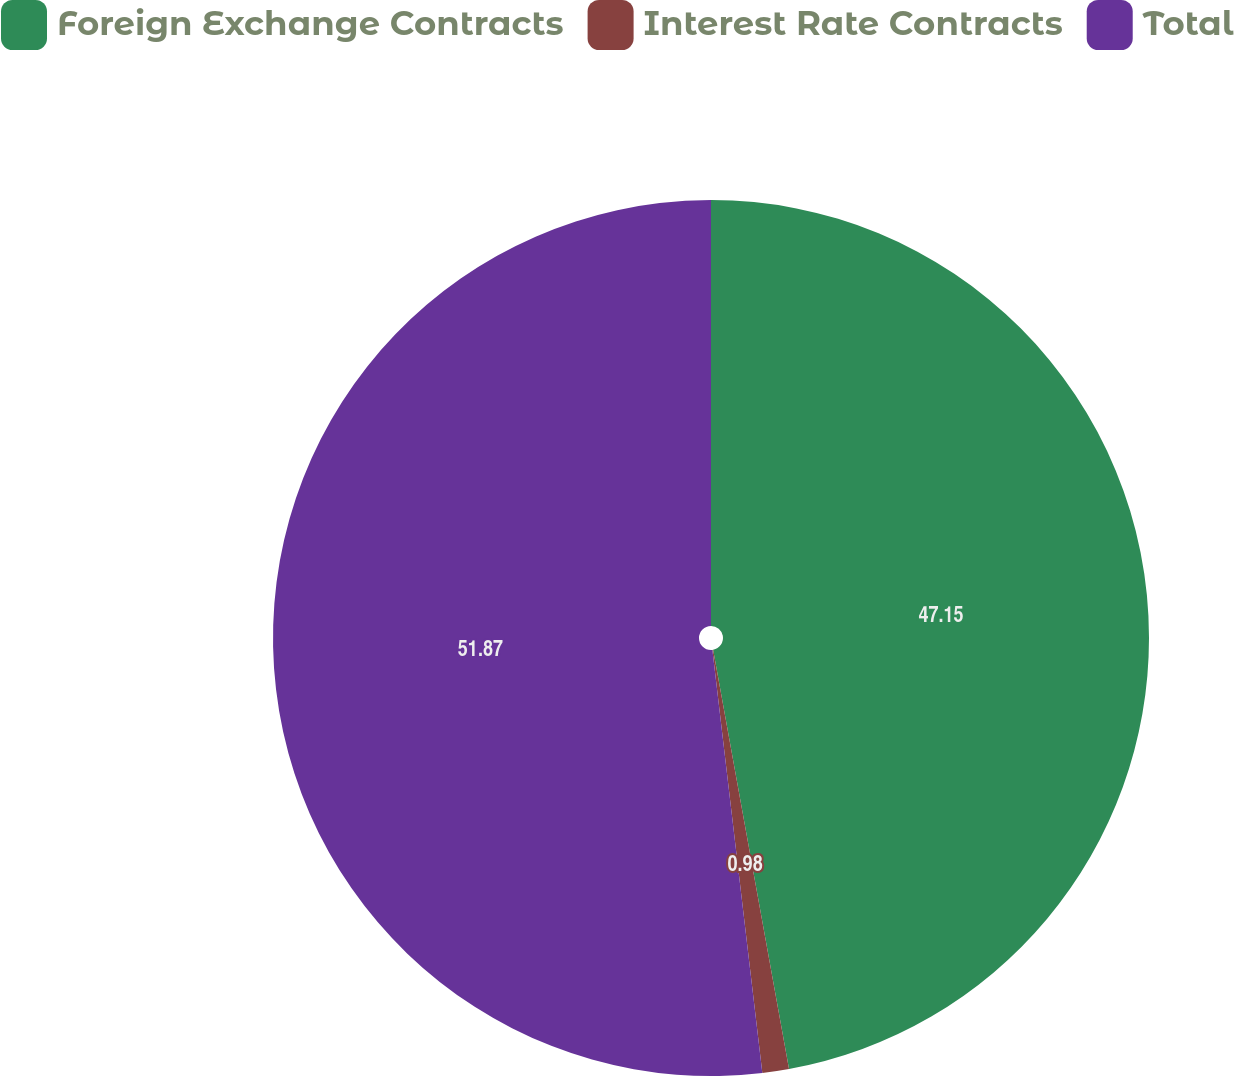Convert chart. <chart><loc_0><loc_0><loc_500><loc_500><pie_chart><fcel>Foreign Exchange Contracts<fcel>Interest Rate Contracts<fcel>Total<nl><fcel>47.15%<fcel>0.98%<fcel>51.87%<nl></chart> 